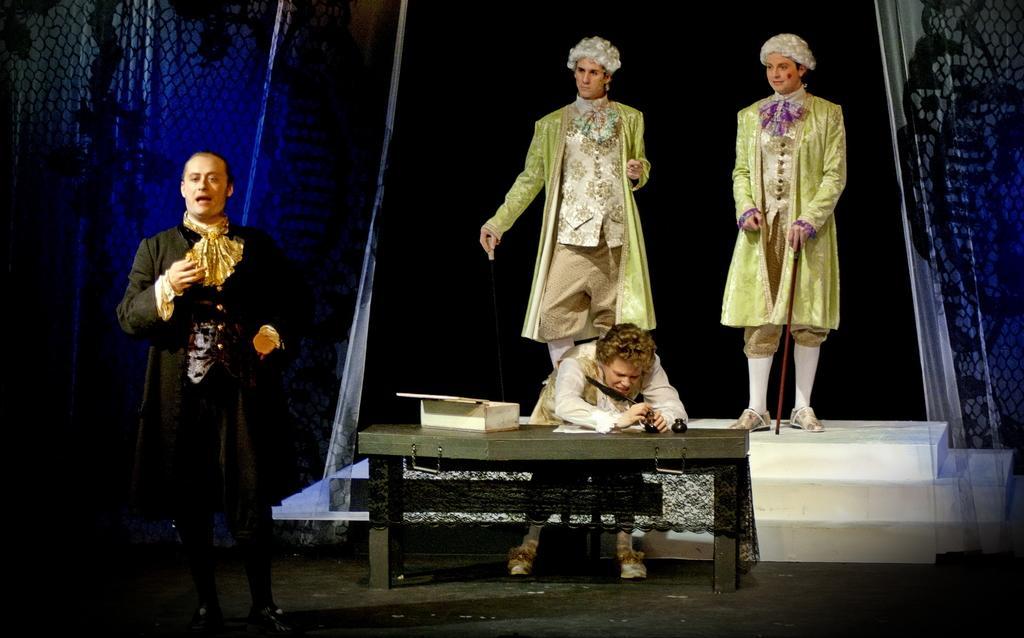In one or two sentences, can you explain what this image depicts? This persons are standing and this person is sitting on a chair. In-front of this person there is a table, on table there is a box. This are curtains. 